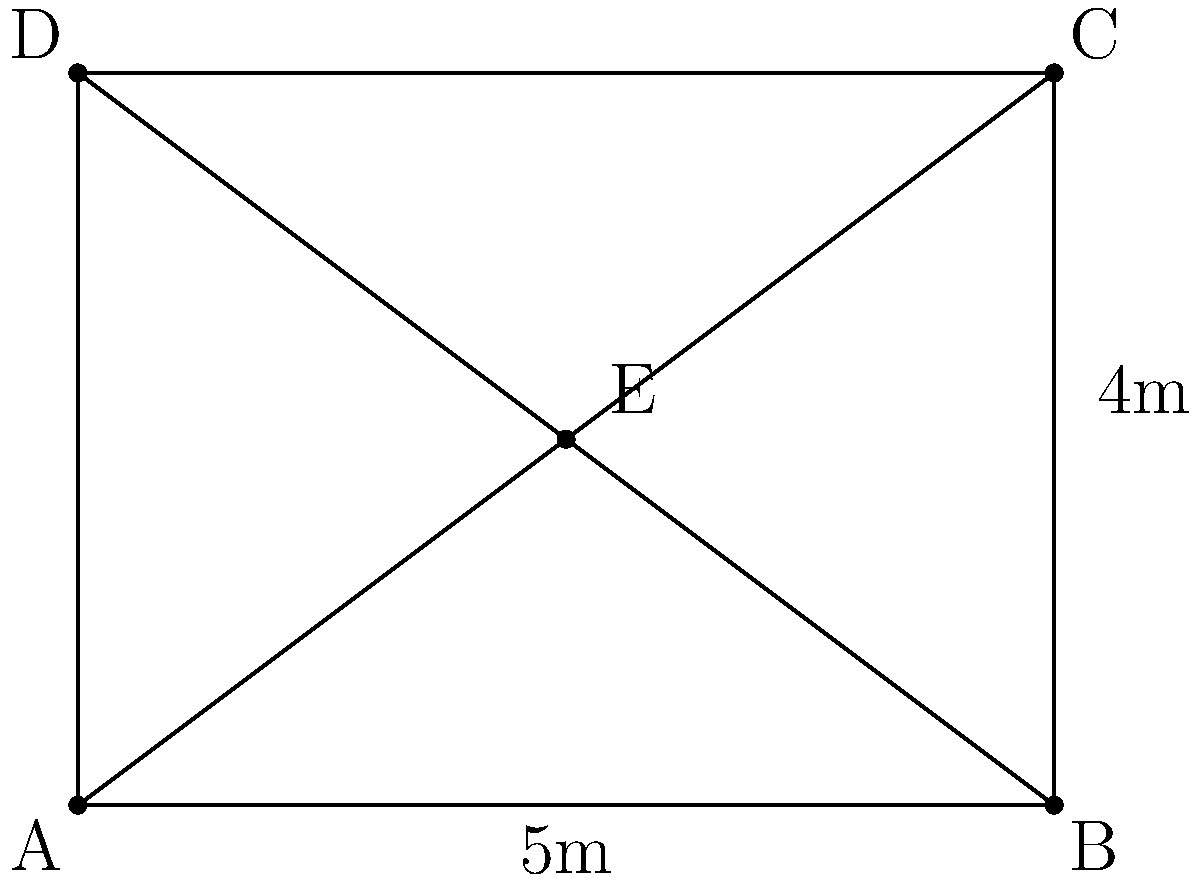In an archaeological excavation site, the layout is represented by a rectangular grid ABCD with diagonals intersecting at point E. If AB = 5m and BC = 4m, which of the following pairs of line segments are congruent?

a) AE and EC
b) BE and ED
c) AE and BE
d) All of the above Let's approach this step-by-step:

1) In a rectangle, the diagonals bisect each other. This means that point E is the midpoint of both diagonals AC and BD.

2) When diagonals of a rectangle intersect, they form four congruent triangles. This is because:
   - The diagonals bisect each other (as stated in step 1)
   - The diagonals of a rectangle are equal in length
   - The angles formed at the intersection point are vertical angles and thus equal

3) Therefore, triangles AEB, BEC, CED, and DEA are all congruent.

4) In congruent triangles, corresponding sides are equal. This means:
   AE ≅ EC (they are corresponding sides in congruent triangles AEB and CED)
   BE ≅ ED (they are corresponding sides in congruent triangles BEC and AED)
   AE ≅ BE (they are corresponding sides in congruent triangles AEB and BEC)

5) Since all these pairs are congruent, all the options given are correct.

Therefore, the correct answer is d) All of the above.
Answer: d) All of the above 